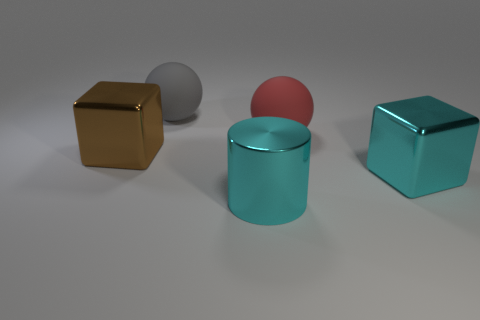How many other objects are there of the same shape as the red matte object?
Ensure brevity in your answer.  1. There is a large red thing; does it have the same shape as the big rubber thing that is to the left of the large shiny cylinder?
Provide a succinct answer. Yes. How many gray things are behind the cyan shiny cube?
Provide a succinct answer. 1. There is a thing that is to the left of the gray matte ball; is its shape the same as the big gray thing?
Ensure brevity in your answer.  No. What color is the block that is right of the big red object?
Your response must be concise. Cyan. What is the shape of the brown thing that is made of the same material as the cyan cube?
Provide a short and direct response. Cube. Are there more cyan metal cylinders that are in front of the big brown object than gray spheres in front of the cylinder?
Make the answer very short. Yes. How many balls have the same size as the cylinder?
Give a very brief answer. 2. Are there fewer brown objects in front of the large brown metallic thing than metal things that are behind the red ball?
Your answer should be compact. No. Is there a gray rubber thing that has the same shape as the red thing?
Offer a terse response. Yes. 